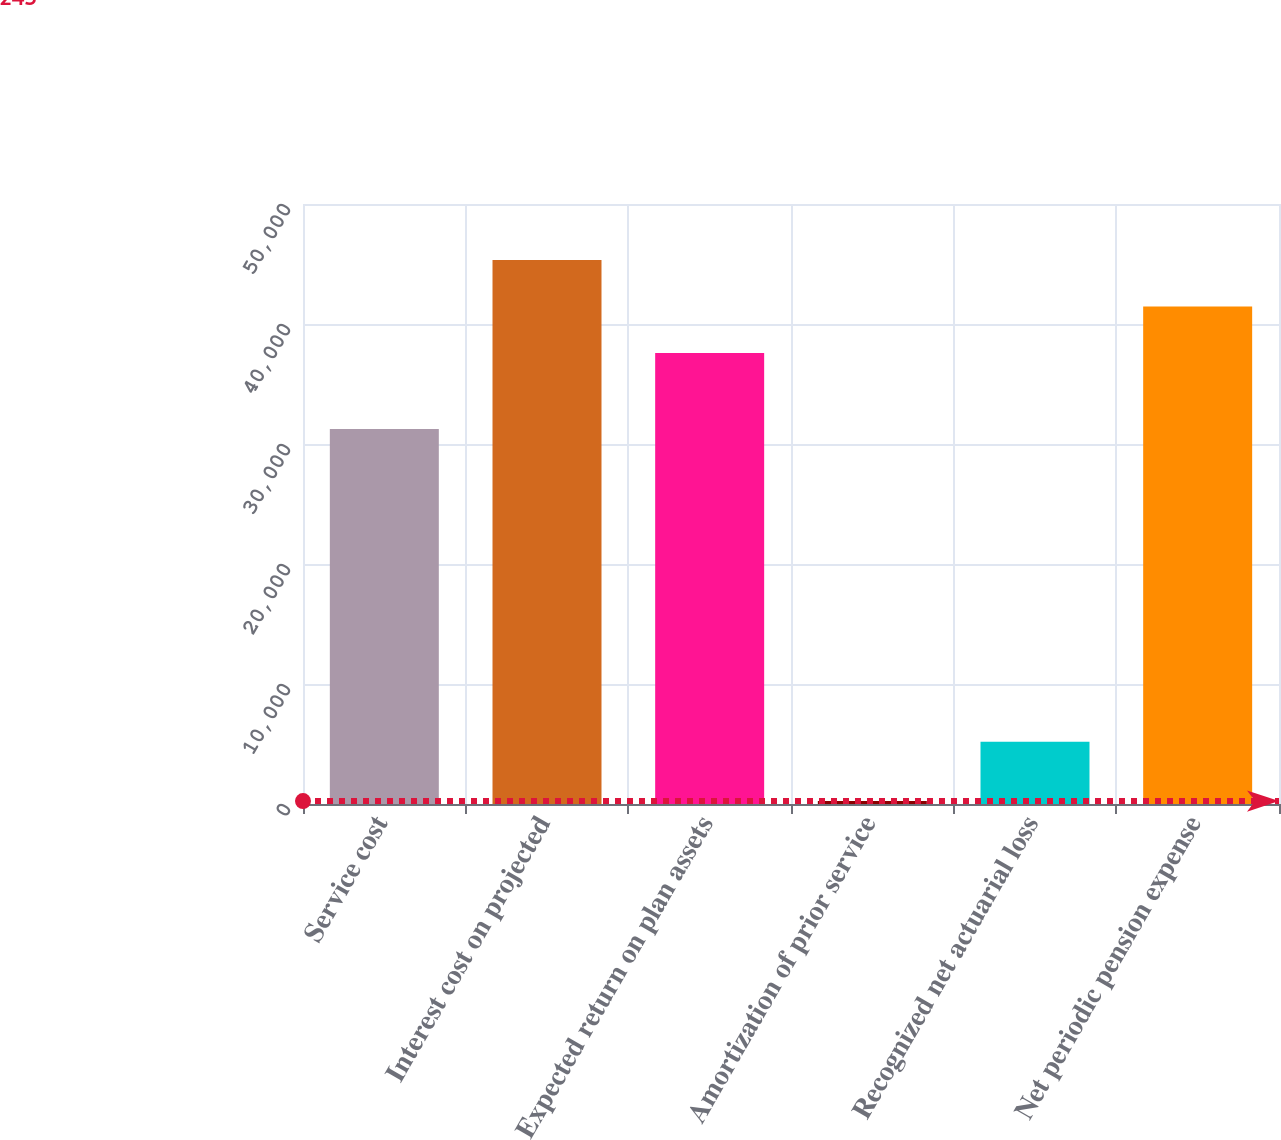Convert chart. <chart><loc_0><loc_0><loc_500><loc_500><bar_chart><fcel>Service cost<fcel>Interest cost on projected<fcel>Expected return on plan assets<fcel>Amortization of prior service<fcel>Recognized net actuarial loss<fcel>Net periodic pension expense<nl><fcel>31240<fcel>45338.2<fcel>37579<fcel>245<fcel>5190<fcel>41458.6<nl></chart> 